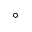Convert formula to latex. <formula><loc_0><loc_0><loc_500><loc_500>^ { \circ }</formula> 